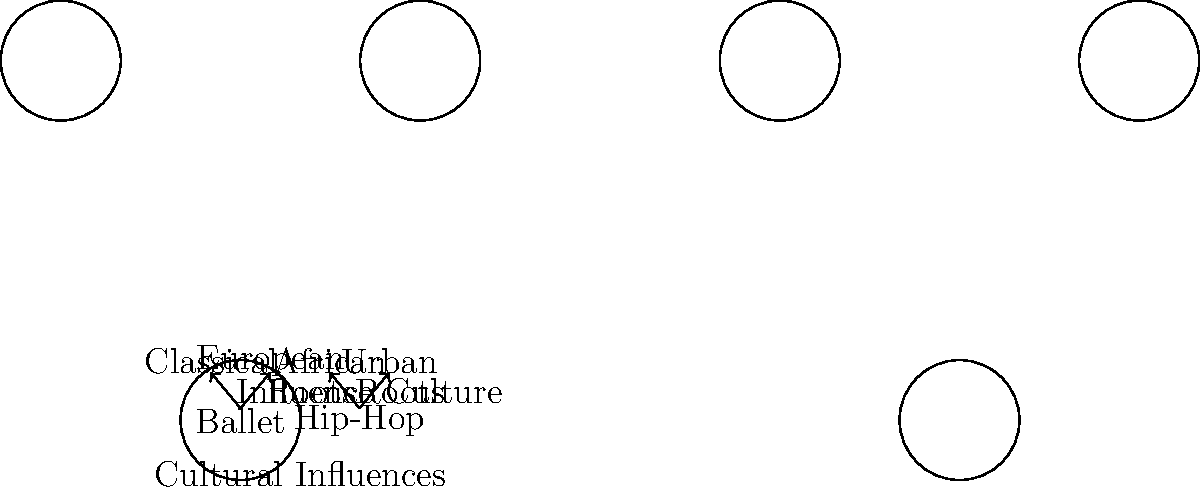In the mind map above, which cultural influence is directly connected to both ballet and hip-hop dance forms? To answer this question, we need to analyze the mind map step-by-step:

1. The mind map shows two main dance forms: Ballet and Hip-Hop.

2. Ballet has two connections:
   a. "Classical" with the label "Influence"
   b. "European" with the label "Roots"

3. Hip-Hop also has two connections:
   a. "African" with the label "Roots"
   b. "Urban" with the label "Culture"

4. We need to identify if any of these cultural influences are directly connected to both ballet and hip-hop.

5. Upon careful examination, we can see that there is no single cultural influence that is directly connected to both ballet and hip-hop in this mind map.

6. Each dance form has its own unique set of cultural influences represented in the diagram.

Therefore, based on the information provided in the mind map, there is no cultural influence that is directly connected to both ballet and hip-hop dance forms.
Answer: None 